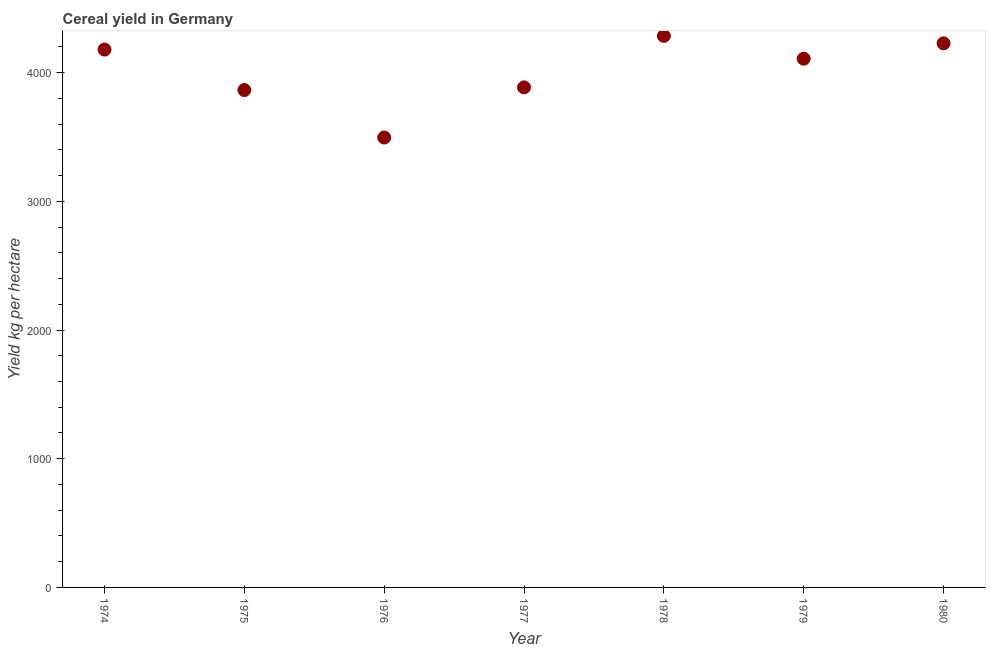What is the cereal yield in 1979?
Give a very brief answer. 4108.25. Across all years, what is the maximum cereal yield?
Your answer should be compact. 4285.19. Across all years, what is the minimum cereal yield?
Provide a short and direct response. 3495.71. In which year was the cereal yield maximum?
Provide a succinct answer. 1978. In which year was the cereal yield minimum?
Offer a terse response. 1976. What is the sum of the cereal yield?
Keep it short and to the point. 2.80e+04. What is the difference between the cereal yield in 1975 and 1979?
Provide a short and direct response. -243.82. What is the average cereal yield per year?
Your answer should be compact. 4006.46. What is the median cereal yield?
Offer a terse response. 4108.25. What is the ratio of the cereal yield in 1976 to that in 1977?
Your answer should be compact. 0.9. Is the cereal yield in 1975 less than that in 1976?
Your answer should be very brief. No. What is the difference between the highest and the second highest cereal yield?
Offer a very short reply. 57.61. Is the sum of the cereal yield in 1978 and 1980 greater than the maximum cereal yield across all years?
Your response must be concise. Yes. What is the difference between the highest and the lowest cereal yield?
Your response must be concise. 789.48. What is the difference between two consecutive major ticks on the Y-axis?
Your answer should be very brief. 1000. Are the values on the major ticks of Y-axis written in scientific E-notation?
Offer a very short reply. No. Does the graph contain any zero values?
Ensure brevity in your answer.  No. Does the graph contain grids?
Provide a succinct answer. No. What is the title of the graph?
Provide a succinct answer. Cereal yield in Germany. What is the label or title of the X-axis?
Ensure brevity in your answer.  Year. What is the label or title of the Y-axis?
Offer a terse response. Yield kg per hectare. What is the Yield kg per hectare in 1974?
Keep it short and to the point. 4178.84. What is the Yield kg per hectare in 1975?
Keep it short and to the point. 3864.43. What is the Yield kg per hectare in 1976?
Ensure brevity in your answer.  3495.71. What is the Yield kg per hectare in 1977?
Make the answer very short. 3885.2. What is the Yield kg per hectare in 1978?
Offer a very short reply. 4285.19. What is the Yield kg per hectare in 1979?
Give a very brief answer. 4108.25. What is the Yield kg per hectare in 1980?
Your response must be concise. 4227.58. What is the difference between the Yield kg per hectare in 1974 and 1975?
Give a very brief answer. 314.41. What is the difference between the Yield kg per hectare in 1974 and 1976?
Your response must be concise. 683.13. What is the difference between the Yield kg per hectare in 1974 and 1977?
Give a very brief answer. 293.64. What is the difference between the Yield kg per hectare in 1974 and 1978?
Your answer should be very brief. -106.35. What is the difference between the Yield kg per hectare in 1974 and 1979?
Keep it short and to the point. 70.59. What is the difference between the Yield kg per hectare in 1974 and 1980?
Offer a very short reply. -48.74. What is the difference between the Yield kg per hectare in 1975 and 1976?
Offer a very short reply. 368.73. What is the difference between the Yield kg per hectare in 1975 and 1977?
Your answer should be very brief. -20.76. What is the difference between the Yield kg per hectare in 1975 and 1978?
Provide a succinct answer. -420.75. What is the difference between the Yield kg per hectare in 1975 and 1979?
Ensure brevity in your answer.  -243.82. What is the difference between the Yield kg per hectare in 1975 and 1980?
Provide a succinct answer. -363.15. What is the difference between the Yield kg per hectare in 1976 and 1977?
Make the answer very short. -389.49. What is the difference between the Yield kg per hectare in 1976 and 1978?
Your response must be concise. -789.48. What is the difference between the Yield kg per hectare in 1976 and 1979?
Offer a terse response. -612.54. What is the difference between the Yield kg per hectare in 1976 and 1980?
Provide a succinct answer. -731.87. What is the difference between the Yield kg per hectare in 1977 and 1978?
Offer a terse response. -399.99. What is the difference between the Yield kg per hectare in 1977 and 1979?
Ensure brevity in your answer.  -223.05. What is the difference between the Yield kg per hectare in 1977 and 1980?
Offer a very short reply. -342.38. What is the difference between the Yield kg per hectare in 1978 and 1979?
Your answer should be compact. 176.94. What is the difference between the Yield kg per hectare in 1978 and 1980?
Offer a very short reply. 57.61. What is the difference between the Yield kg per hectare in 1979 and 1980?
Give a very brief answer. -119.33. What is the ratio of the Yield kg per hectare in 1974 to that in 1975?
Offer a very short reply. 1.08. What is the ratio of the Yield kg per hectare in 1974 to that in 1976?
Ensure brevity in your answer.  1.2. What is the ratio of the Yield kg per hectare in 1974 to that in 1977?
Your answer should be compact. 1.08. What is the ratio of the Yield kg per hectare in 1974 to that in 1979?
Keep it short and to the point. 1.02. What is the ratio of the Yield kg per hectare in 1975 to that in 1976?
Keep it short and to the point. 1.1. What is the ratio of the Yield kg per hectare in 1975 to that in 1977?
Your response must be concise. 0.99. What is the ratio of the Yield kg per hectare in 1975 to that in 1978?
Keep it short and to the point. 0.9. What is the ratio of the Yield kg per hectare in 1975 to that in 1979?
Make the answer very short. 0.94. What is the ratio of the Yield kg per hectare in 1975 to that in 1980?
Provide a succinct answer. 0.91. What is the ratio of the Yield kg per hectare in 1976 to that in 1977?
Offer a very short reply. 0.9. What is the ratio of the Yield kg per hectare in 1976 to that in 1978?
Your answer should be compact. 0.82. What is the ratio of the Yield kg per hectare in 1976 to that in 1979?
Offer a very short reply. 0.85. What is the ratio of the Yield kg per hectare in 1976 to that in 1980?
Your response must be concise. 0.83. What is the ratio of the Yield kg per hectare in 1977 to that in 1978?
Offer a terse response. 0.91. What is the ratio of the Yield kg per hectare in 1977 to that in 1979?
Offer a very short reply. 0.95. What is the ratio of the Yield kg per hectare in 1977 to that in 1980?
Make the answer very short. 0.92. What is the ratio of the Yield kg per hectare in 1978 to that in 1979?
Your answer should be compact. 1.04. 